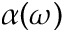<formula> <loc_0><loc_0><loc_500><loc_500>\alpha ( \omega )</formula> 